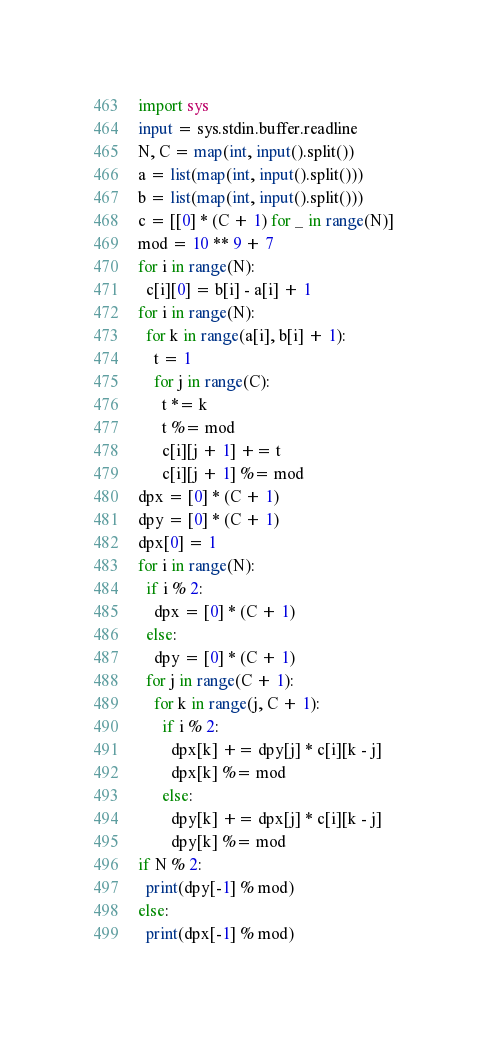Convert code to text. <code><loc_0><loc_0><loc_500><loc_500><_Python_>import sys
input = sys.stdin.buffer.readline
N, C = map(int, input().split())
a = list(map(int, input().split()))
b = list(map(int, input().split()))
c = [[0] * (C + 1) for _ in range(N)]
mod = 10 ** 9 + 7
for i in range(N):
  c[i][0] = b[i] - a[i] + 1
for i in range(N):
  for k in range(a[i], b[i] + 1):
    t = 1
    for j in range(C):
      t *= k
      t %= mod 
      c[i][j + 1] += t
      c[i][j + 1] %= mod
dpx = [0] * (C + 1)
dpy = [0] * (C + 1)
dpx[0] = 1
for i in range(N):
  if i % 2:
    dpx = [0] * (C + 1)
  else:
    dpy = [0] * (C + 1)
  for j in range(C + 1):
    for k in range(j, C + 1):
      if i % 2:
        dpx[k] += dpy[j] * c[i][k - j]
        dpx[k] %= mod
      else:
        dpy[k] += dpx[j] * c[i][k - j]
        dpy[k] %= mod
if N % 2:
  print(dpy[-1] % mod)
else:
  print(dpx[-1] % mod)</code> 